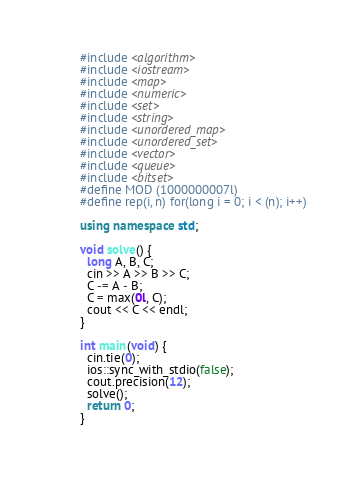<code> <loc_0><loc_0><loc_500><loc_500><_C++_>#include <algorithm>
#include <iostream>
#include <map>
#include <numeric>
#include <set>
#include <string>
#include <unordered_map>
#include <unordered_set>
#include <vector>
#include <queue>
#include <bitset>
#define MOD (1000000007l)
#define rep(i, n) for(long i = 0; i < (n); i++)

using namespace std;

void solve() {
  long A, B, C;
  cin >> A >> B >> C;
  C -= A - B;
  C = max(0l, C);
  cout << C << endl;
}

int main(void) {
  cin.tie(0);
  ios::sync_with_stdio(false);
  cout.precision(12);
  solve();
  return 0;
}
 </code> 